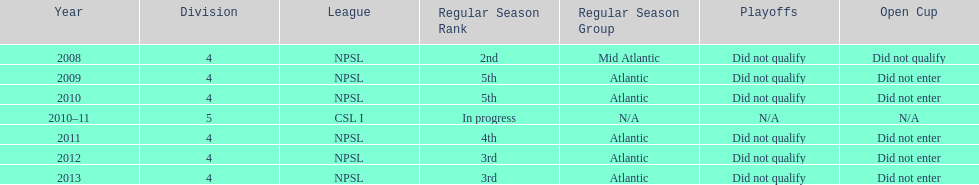What was the last year they came in 3rd place 2013. 